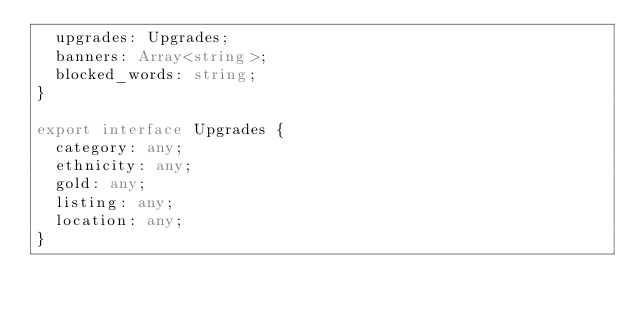Convert code to text. <code><loc_0><loc_0><loc_500><loc_500><_TypeScript_>  upgrades: Upgrades;
  banners: Array<string>;
  blocked_words: string;
}

export interface Upgrades {
  category: any;
  ethnicity: any;
  gold: any;
  listing: any;
  location: any;
}
</code> 